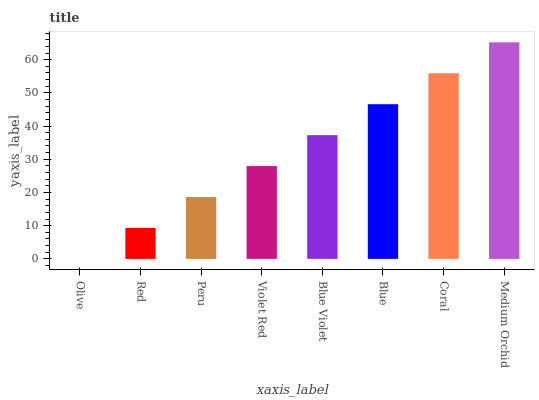Is Red the minimum?
Answer yes or no. No. Is Red the maximum?
Answer yes or no. No. Is Red greater than Olive?
Answer yes or no. Yes. Is Olive less than Red?
Answer yes or no. Yes. Is Olive greater than Red?
Answer yes or no. No. Is Red less than Olive?
Answer yes or no. No. Is Blue Violet the high median?
Answer yes or no. Yes. Is Violet Red the low median?
Answer yes or no. Yes. Is Coral the high median?
Answer yes or no. No. Is Medium Orchid the low median?
Answer yes or no. No. 